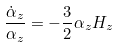<formula> <loc_0><loc_0><loc_500><loc_500>\frac { \dot { \alpha } _ { z } } { \alpha _ { z } } = - \frac { 3 } { 2 } \alpha _ { z } H _ { z }</formula> 